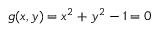Convert formula to latex. <formula><loc_0><loc_0><loc_500><loc_500>g ( x , y ) = x ^ { 2 } + y ^ { 2 } - 1 = 0</formula> 